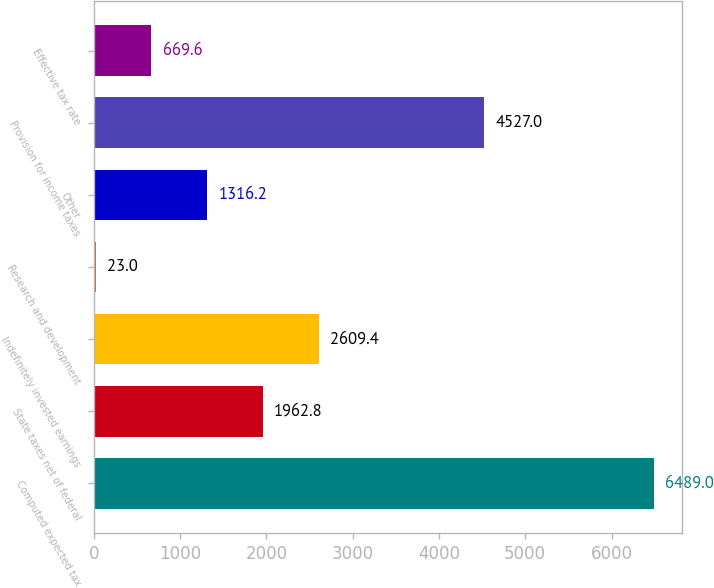<chart> <loc_0><loc_0><loc_500><loc_500><bar_chart><fcel>Computed expected tax<fcel>State taxes net of federal<fcel>Indefinitely invested earnings<fcel>Research and development<fcel>Other<fcel>Provision for income taxes<fcel>Effective tax rate<nl><fcel>6489<fcel>1962.8<fcel>2609.4<fcel>23<fcel>1316.2<fcel>4527<fcel>669.6<nl></chart> 